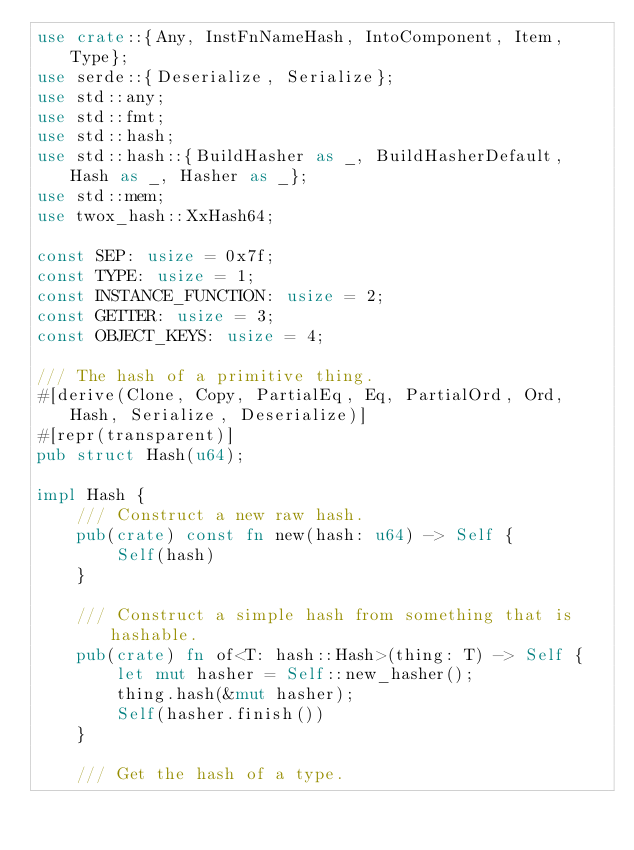<code> <loc_0><loc_0><loc_500><loc_500><_Rust_>use crate::{Any, InstFnNameHash, IntoComponent, Item, Type};
use serde::{Deserialize, Serialize};
use std::any;
use std::fmt;
use std::hash;
use std::hash::{BuildHasher as _, BuildHasherDefault, Hash as _, Hasher as _};
use std::mem;
use twox_hash::XxHash64;

const SEP: usize = 0x7f;
const TYPE: usize = 1;
const INSTANCE_FUNCTION: usize = 2;
const GETTER: usize = 3;
const OBJECT_KEYS: usize = 4;

/// The hash of a primitive thing.
#[derive(Clone, Copy, PartialEq, Eq, PartialOrd, Ord, Hash, Serialize, Deserialize)]
#[repr(transparent)]
pub struct Hash(u64);

impl Hash {
    /// Construct a new raw hash.
    pub(crate) const fn new(hash: u64) -> Self {
        Self(hash)
    }

    /// Construct a simple hash from something that is hashable.
    pub(crate) fn of<T: hash::Hash>(thing: T) -> Self {
        let mut hasher = Self::new_hasher();
        thing.hash(&mut hasher);
        Self(hasher.finish())
    }

    /// Get the hash of a type.</code> 